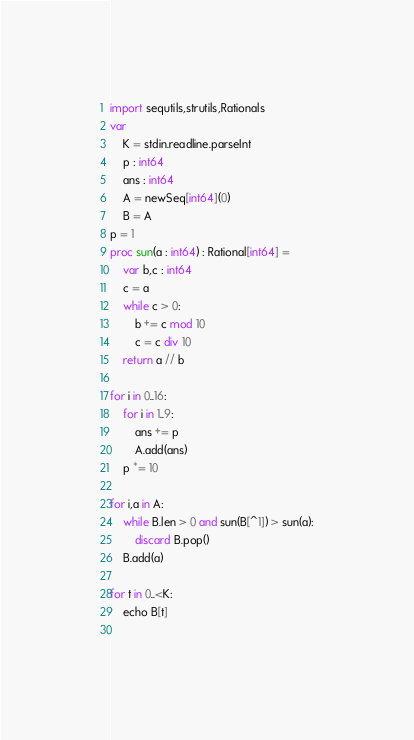Convert code to text. <code><loc_0><loc_0><loc_500><loc_500><_Nim_>import sequtils,strutils,Rationals
var
    K = stdin.readline.parseInt
    p : int64
    ans : int64
    A = newSeq[int64](0)
    B = A
p = 1
proc sun(a : int64) : Rational[int64] =
    var b,c : int64
    c = a
    while c > 0:
        b += c mod 10
        c = c div 10
    return a // b

for i in 0..16:
    for i in 1..9:
        ans += p
        A.add(ans)
    p *= 10
    
for i,a in A:
    while B.len > 0 and sun(B[^1]) > sun(a):
        discard B.pop()
    B.add(a)

for t in 0..<K:
    echo B[t]
    </code> 